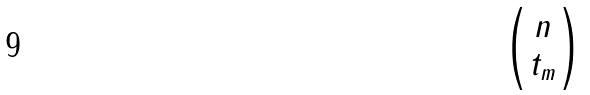<formula> <loc_0><loc_0><loc_500><loc_500>\begin{pmatrix} n \\ t _ { m } \end{pmatrix}</formula> 